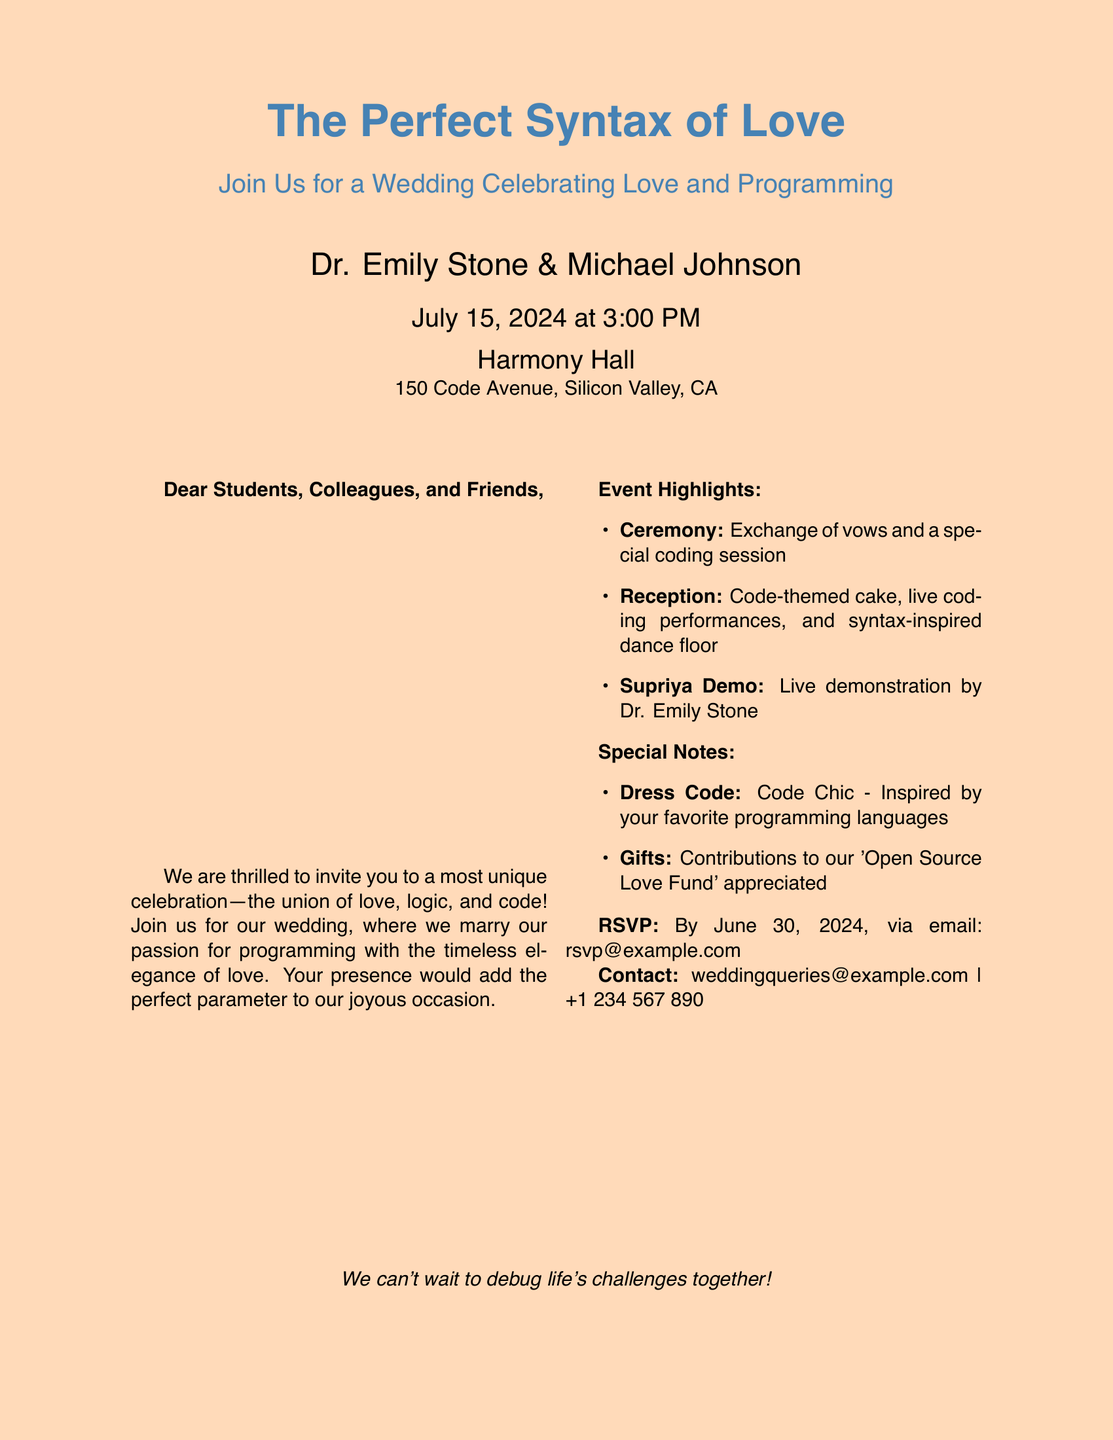What is the name of the bride? The name of the bride is listed in the document as Dr. Emily Stone.
Answer: Dr. Emily Stone What is the date of the wedding? The date of the wedding is specified in the document as July 15, 2024.
Answer: July 15, 2024 What is the venue of the wedding? The venue is provided in the document as Harmony Hall.
Answer: Harmony Hall What is the dress code for the wedding? The dress code is outlined in the document as Code Chic.
Answer: Code Chic What is the RSVP deadline? The document mentions that the RSVP deadline is June 30, 2024.
Answer: June 30, 2024 What type of demonstration is scheduled? The document indicates that there will be a live demonstration by Dr. Emily Stone.
Answer: Supriya Demo What is encouraged as gifts? The document suggests contributions to an 'Open Source Love Fund' as gifts.
Answer: 'Open Source Love Fund' How is the wedding themed? The document describes the wedding as a celebration of love and programming.
Answer: Love and programming What special feature is included at the reception? The document lists a code-themed cake as a special feature at the reception.
Answer: Code-themed cake 